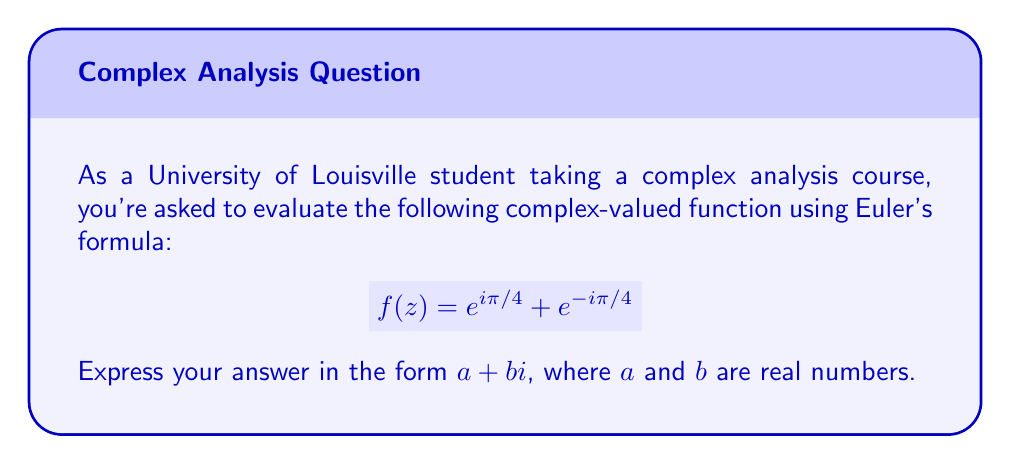What is the answer to this math problem? Let's approach this step-by-step:

1) Recall Euler's formula: $e^{ix} = \cos x + i \sin x$

2) For $e^{i\pi/4}$:
   $$e^{i\pi/4} = \cos(\pi/4) + i\sin(\pi/4)$$

3) For $e^{-i\pi/4}$:
   $$e^{-i\pi/4} = \cos(-\pi/4) + i\sin(-\pi/4) = \cos(\pi/4) - i\sin(\pi/4)$$
   (Since cosine is an even function and sine is an odd function)

4) Now, let's add these together:
   $$f(z) = e^{i\pi/4} + e^{-i\pi/4} = (\cos(\pi/4) + i\sin(\pi/4)) + (\cos(\pi/4) - i\sin(\pi/4))$$

5) Simplify:
   $$f(z) = 2\cos(\pi/4) + 0i$$

6) Recall that $\cos(\pi/4) = \frac{1}{\sqrt{2}}$:
   $$f(z) = 2 \cdot \frac{1}{\sqrt{2}} + 0i = \sqrt{2} + 0i$$

Therefore, $f(z) = \sqrt{2} + 0i$, which is in the form $a + bi$ where $a = \sqrt{2}$ and $b = 0$.
Answer: $\sqrt{2} + 0i$ 